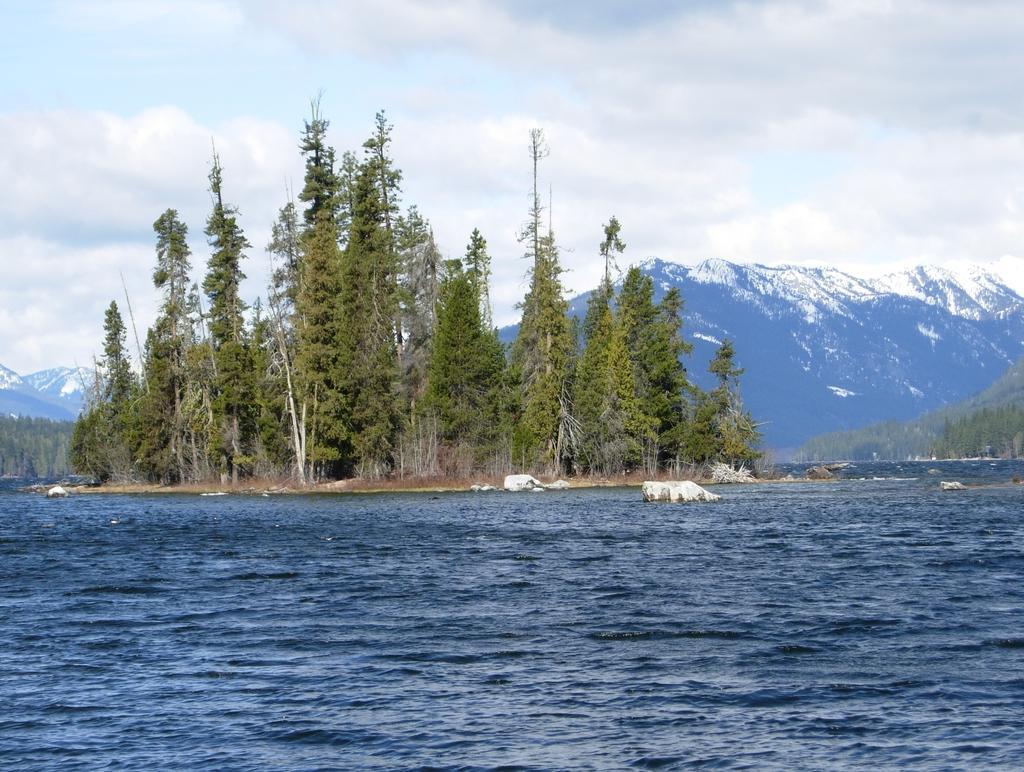Describe this image in one or two sentences. Completely an outdoor picture. This is a freshwater river. Far there are number of trees in green color. Far there are number of mountains covered with snow. Sky is cloudy and it is in white color. 